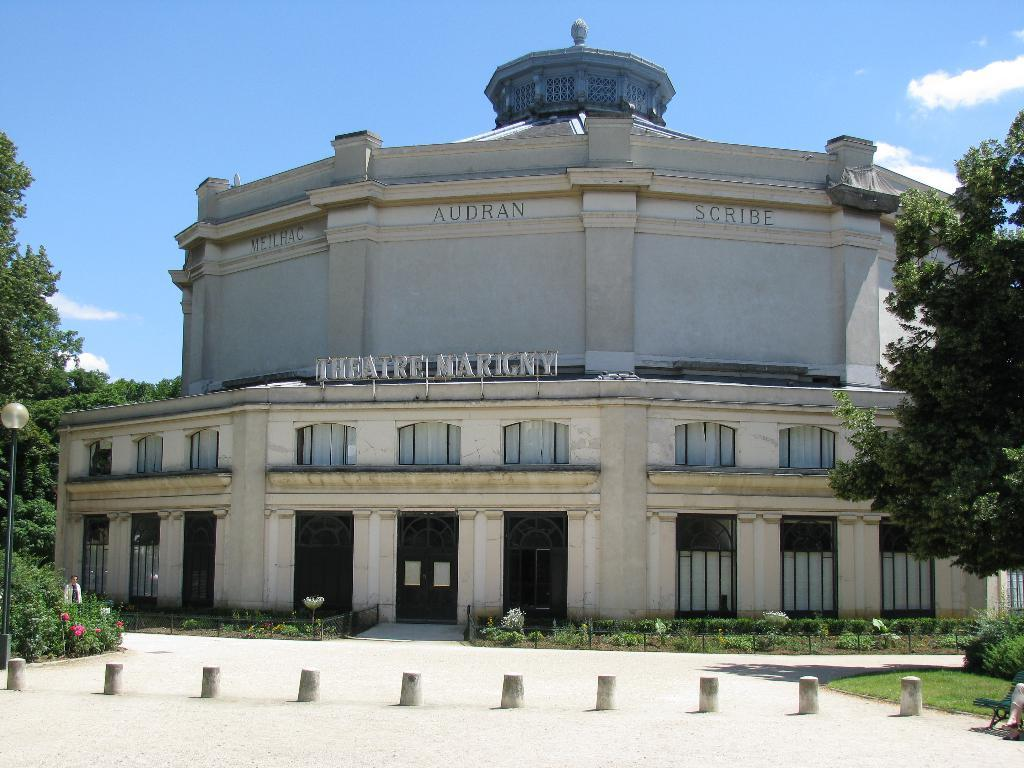What objects can be seen on the ground in the image? There are poles on the ground in the image. What structures can be seen in the background of the image? There is a building and a light with a pole in the background of the image. What type of natural elements are visible in the background of the image? There are trees, plants, flowers, and the sky visible in the background of the image. Are there any people present in the image? Yes, there is a person in the background of the image. What type of table is visible in the image? There is no table present in the image. What is the limit of the sky in the image? The sky is not limited in the image; it extends beyond the boundaries of the photograph. 